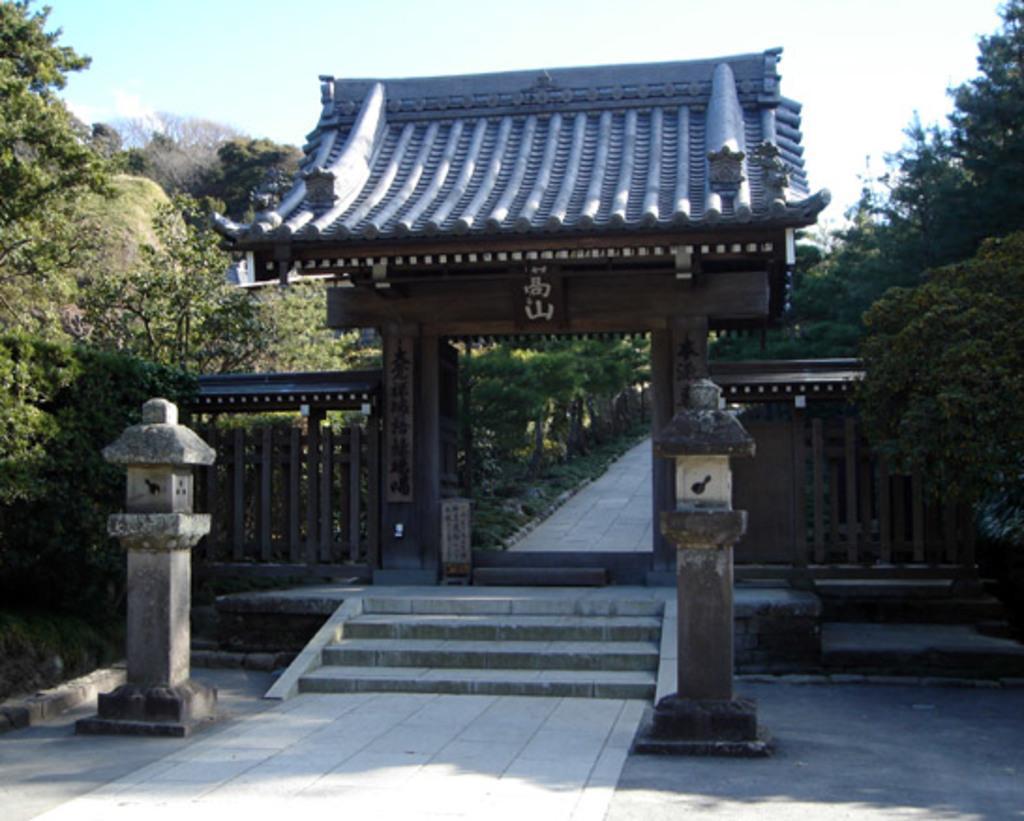Can you describe this image briefly? In this image I can see the ground, two poles, few stairs, few trees, the arch and the path. In the background I can see the sky. 